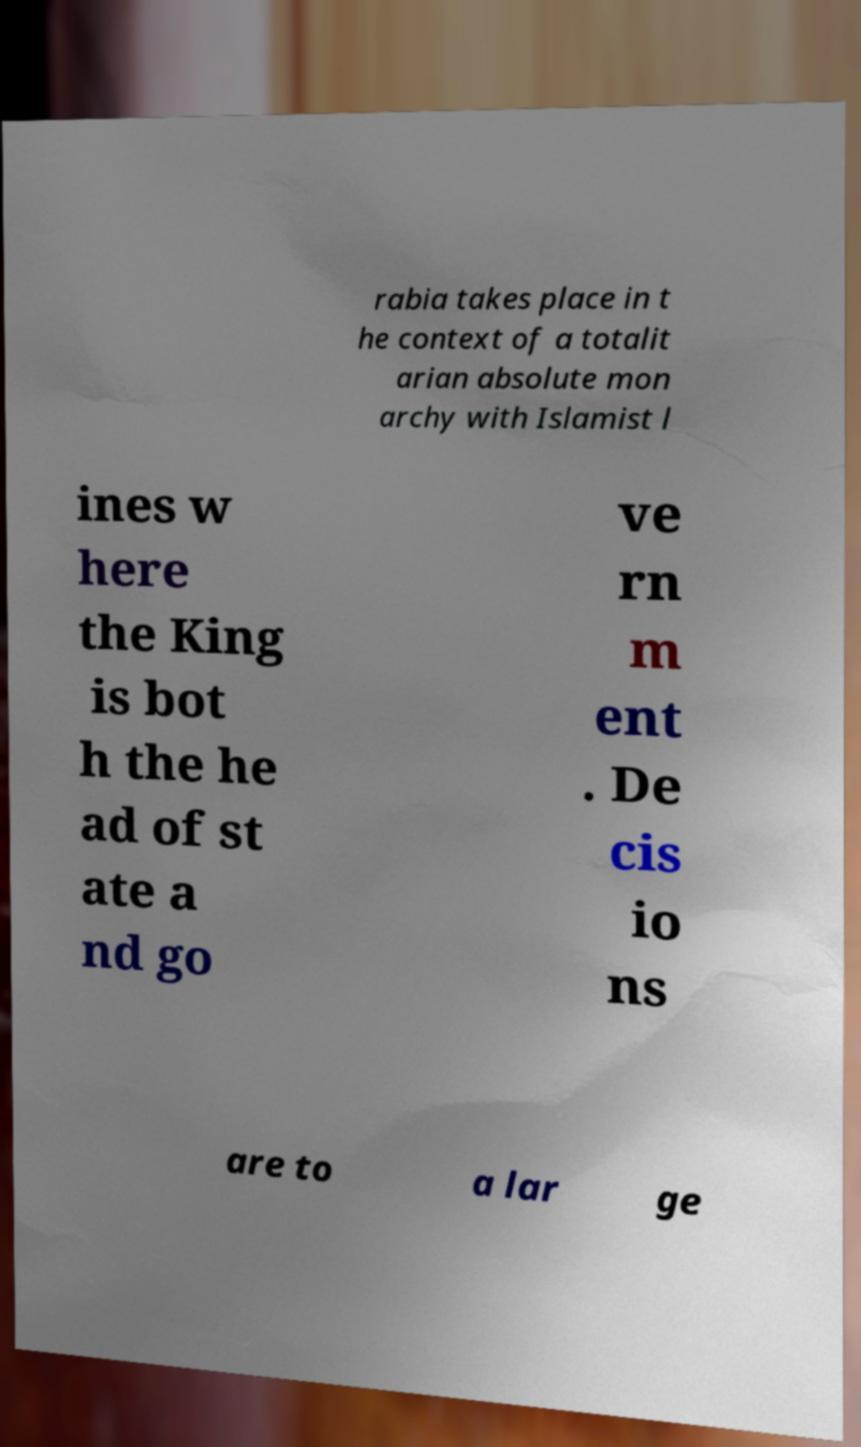Please identify and transcribe the text found in this image. rabia takes place in t he context of a totalit arian absolute mon archy with Islamist l ines w here the King is bot h the he ad of st ate a nd go ve rn m ent . De cis io ns are to a lar ge 